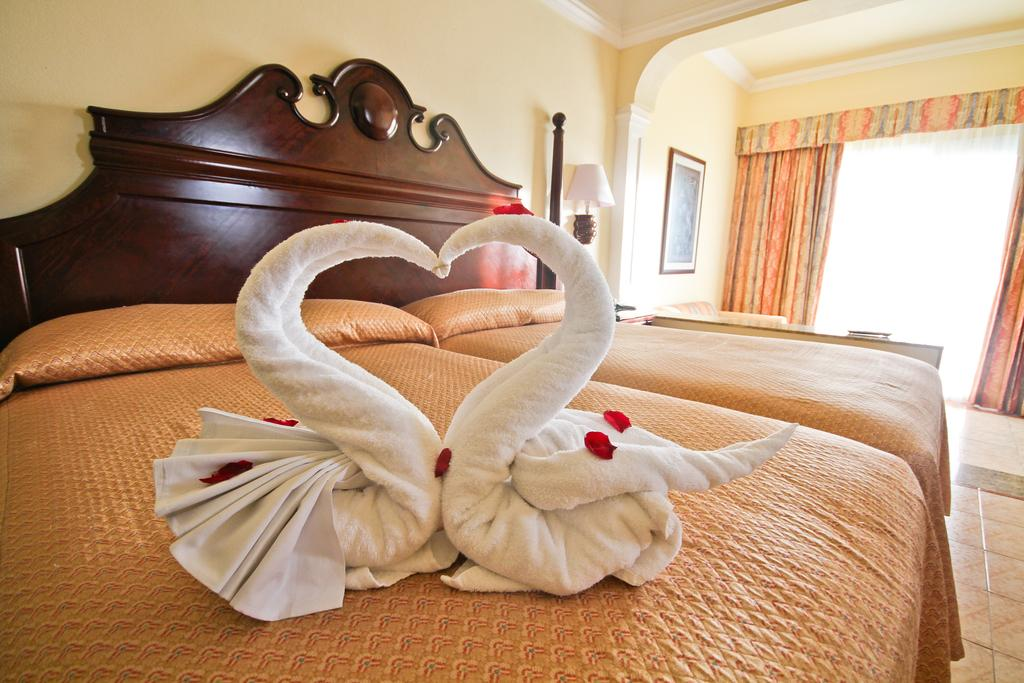What type of furniture is present in the image? There is a bed in the image. What is placed on the bed? There is a pillow in the image. What is covering the bed? There is a blanket in the image. What can be seen in the background of the image? There is a window in the image. How many cows are visible in the image? There are no cows present in the image. What advice might the uncle in the image be giving? There is no uncle present in the image, so it is not possible to determine what advice he might be giving. 